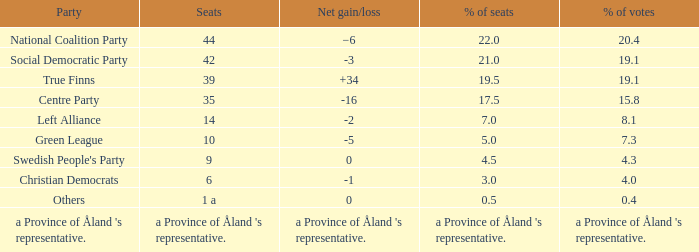1% of the vote, how many seats were maintained? 14.0. 